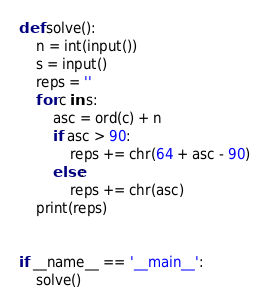Convert code to text. <code><loc_0><loc_0><loc_500><loc_500><_Python_>def solve():
    n = int(input())
    s = input()
    reps = ''
    for c in s:
        asc = ord(c) + n
        if asc > 90:
            reps += chr(64 + asc - 90)
        else:
            reps += chr(asc)
    print(reps)


if __name__ == '__main__':
    solve()
</code> 